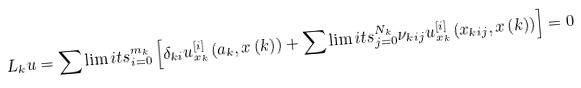<formula> <loc_0><loc_0><loc_500><loc_500>L _ { k } u = \sum \lim i t s _ { i = 0 } ^ { m _ { k } } \left [ \delta _ { k i } u _ { x _ { k } } ^ { \left [ i \right ] } \left ( a _ { k } , x \left ( k \right ) \right ) + \sum \lim i t s _ { j = 0 } ^ { N _ { k } } \nu _ { k i j } u _ { x _ { k } } ^ { \left [ i \right ] } \left ( x _ { k i j } , x \left ( k \right ) \right ) \right ] = 0</formula> 